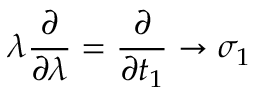<formula> <loc_0><loc_0><loc_500><loc_500>\lambda \frac { \partial } { \partial \lambda } = \frac { \partial } { \partial t _ { 1 } } \rightarrow \sigma _ { 1 }</formula> 